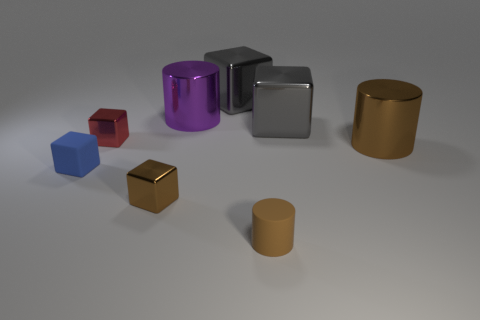Is the number of large yellow metal objects less than the number of cylinders? yes 